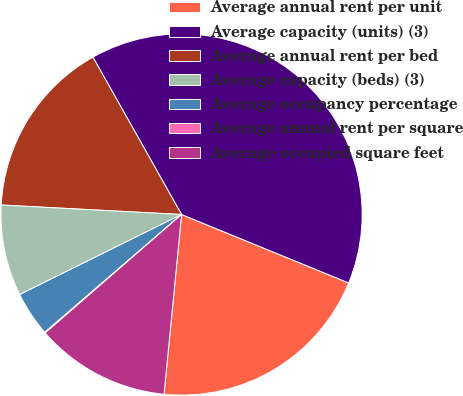<chart> <loc_0><loc_0><loc_500><loc_500><pie_chart><fcel>Average annual rent per unit<fcel>Average capacity (units) (3)<fcel>Average annual rent per bed<fcel>Average capacity (beds) (3)<fcel>Average occupancy percentage<fcel>Average annual rent per square<fcel>Average occupied square feet<nl><fcel>20.36%<fcel>39.35%<fcel>16.0%<fcel>8.15%<fcel>4.0%<fcel>0.07%<fcel>12.07%<nl></chart> 